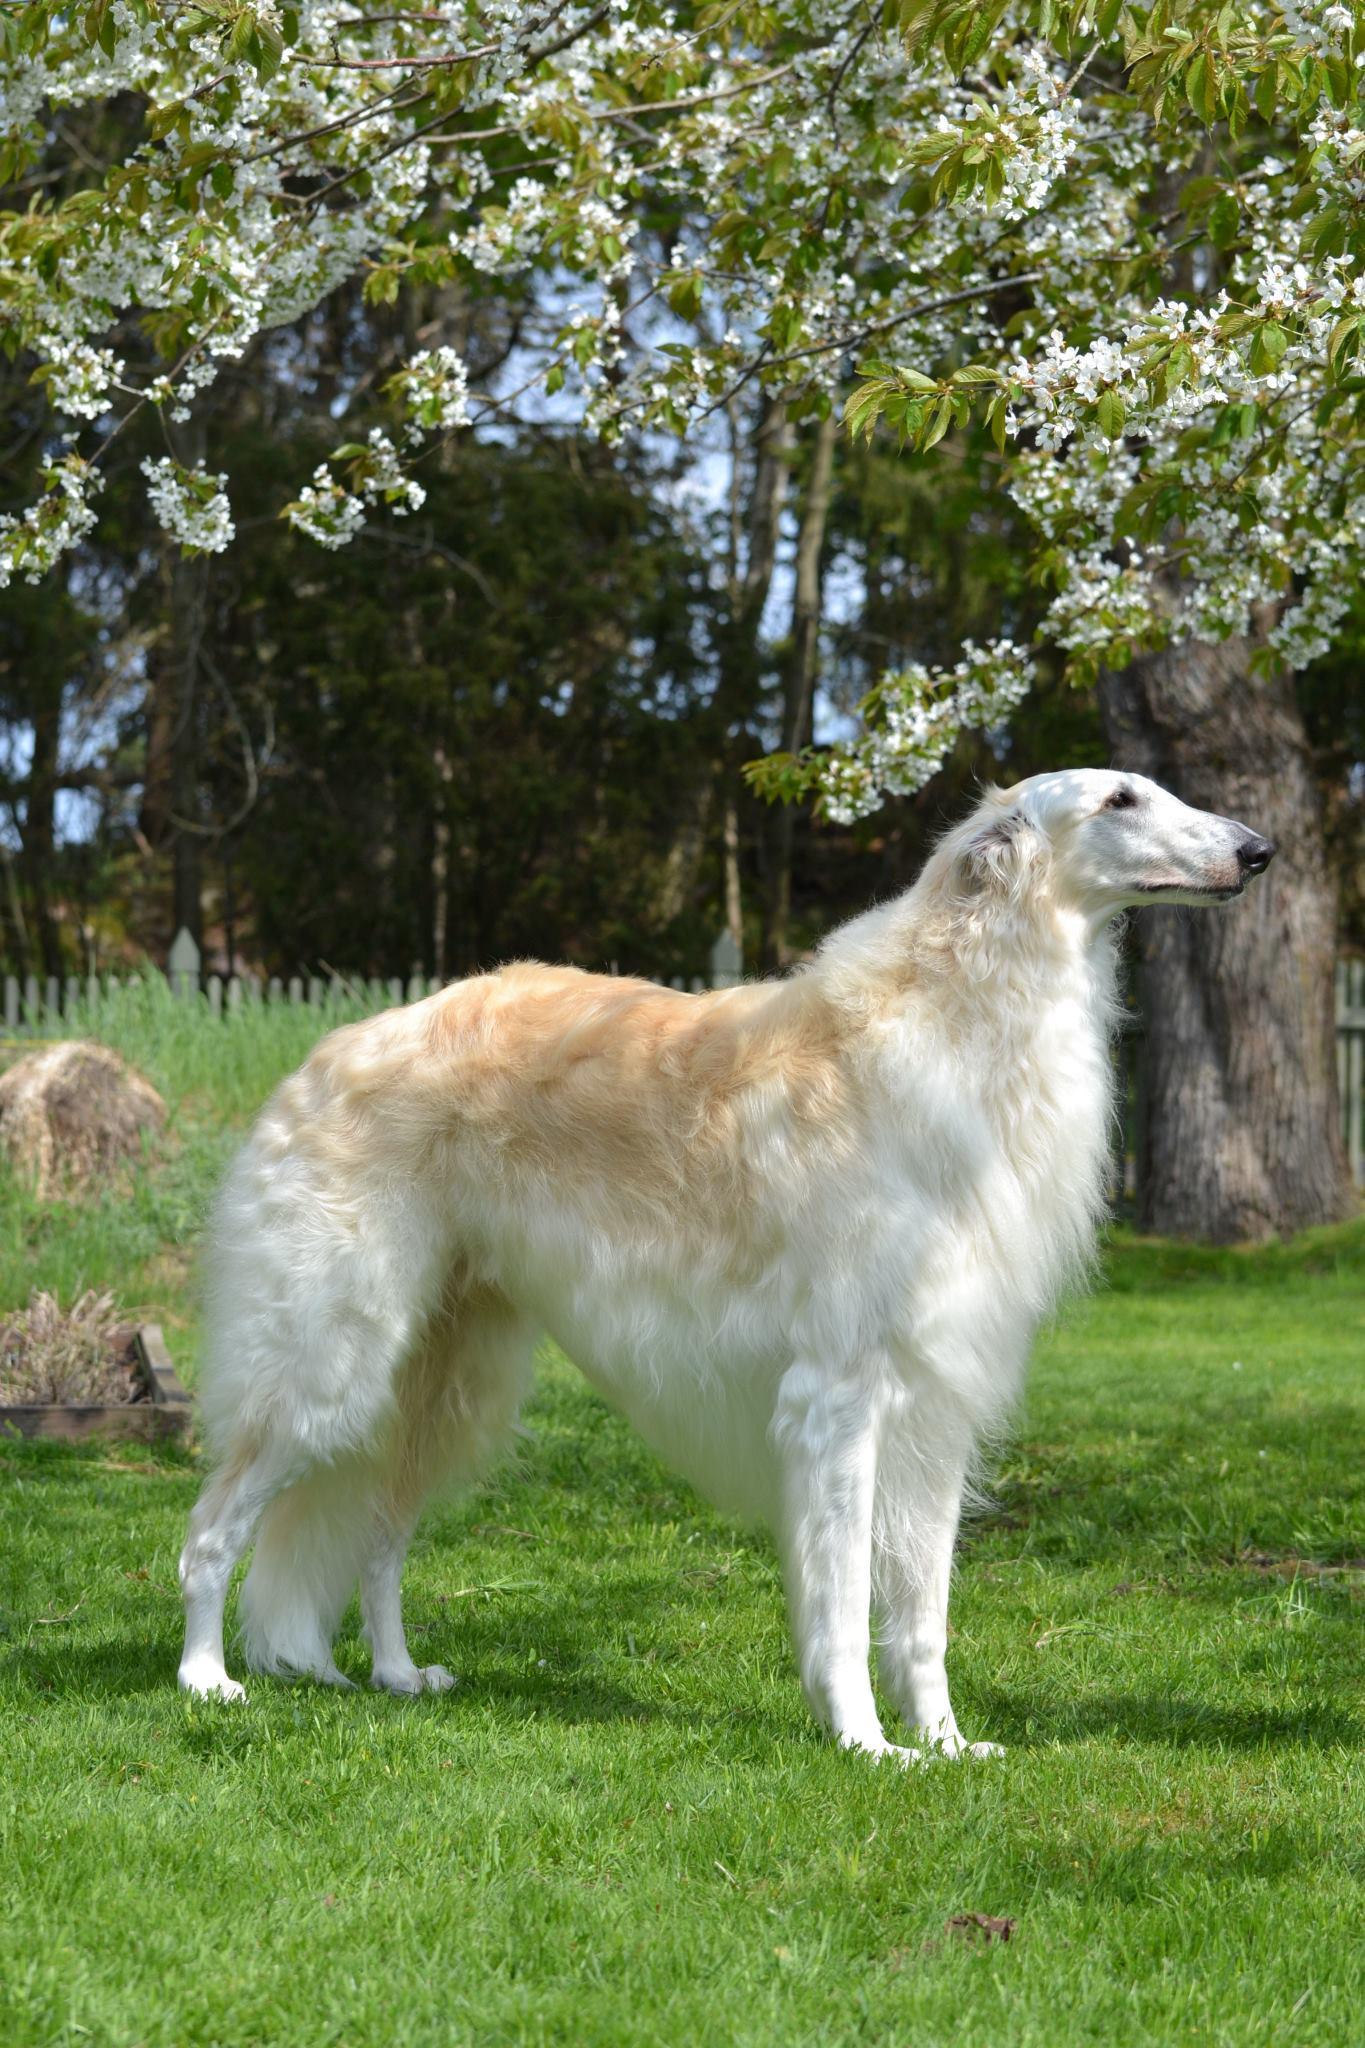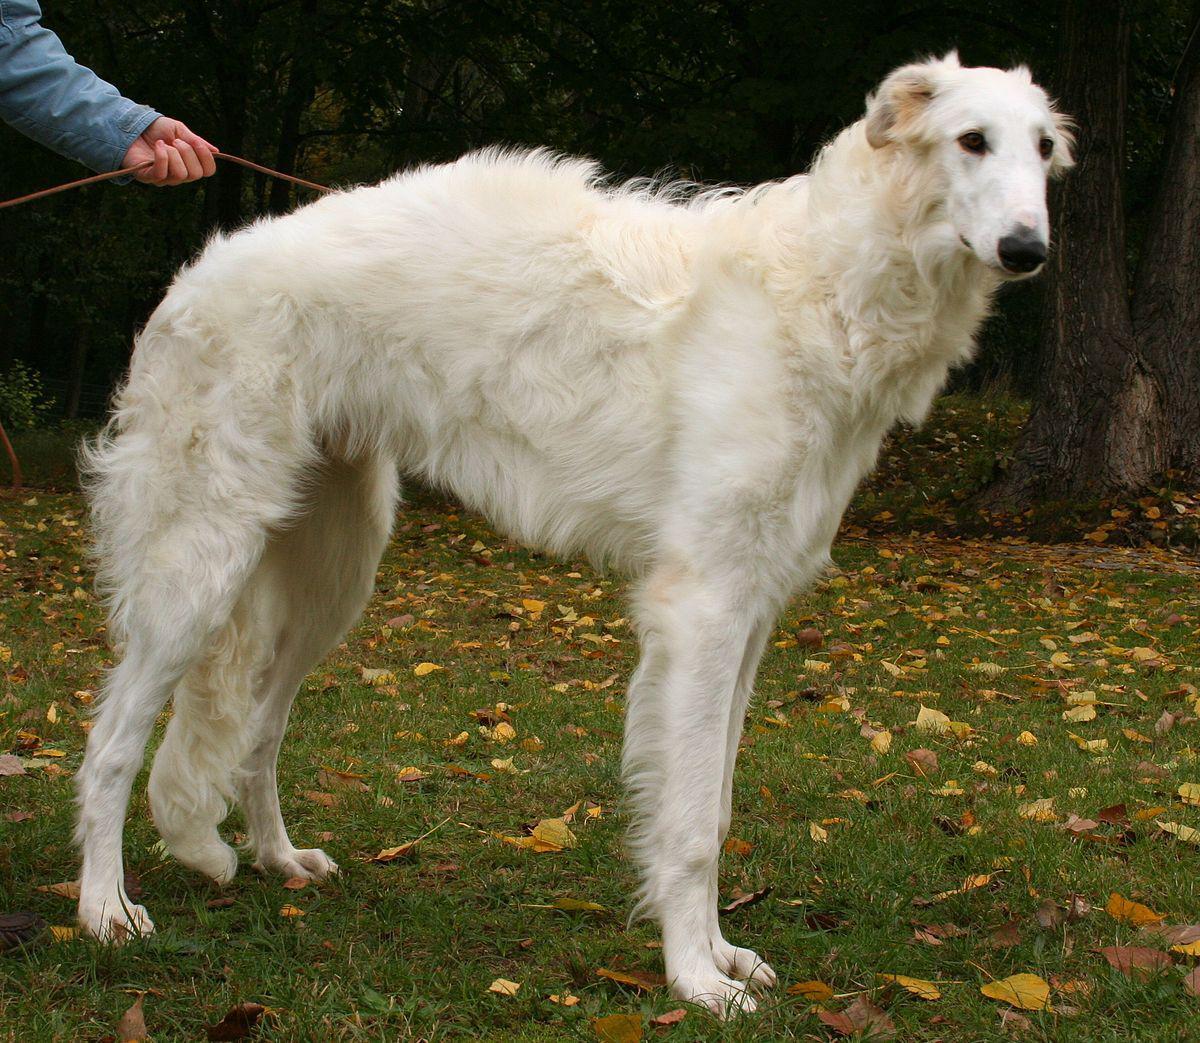The first image is the image on the left, the second image is the image on the right. For the images displayed, is the sentence "Each image shows one hound standing outdoors." factually correct? Answer yes or no. Yes. The first image is the image on the left, the second image is the image on the right. For the images displayed, is the sentence "There are 2 dogs standing on grass." factually correct? Answer yes or no. Yes. 